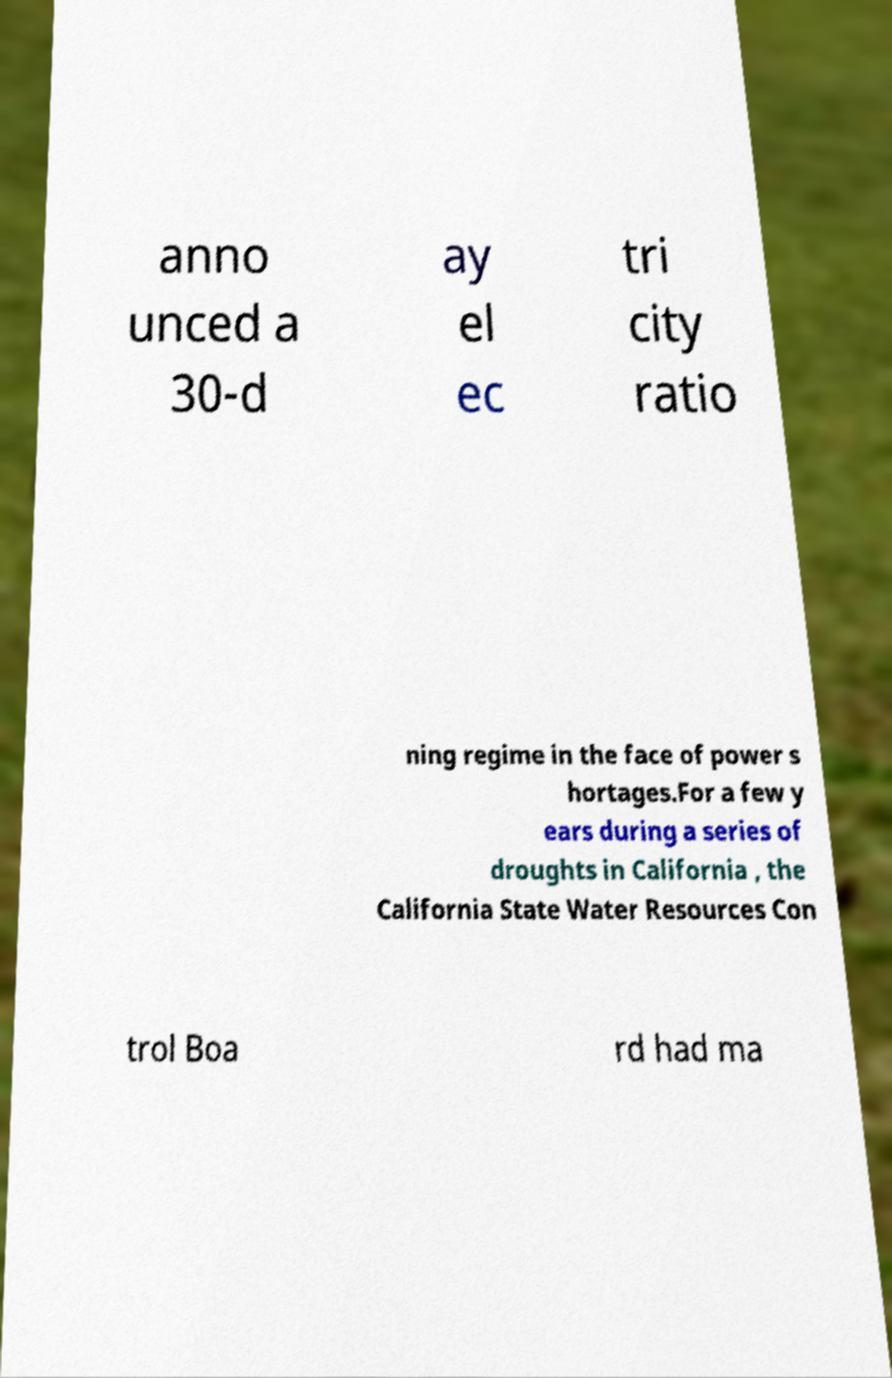Please identify and transcribe the text found in this image. anno unced a 30-d ay el ec tri city ratio ning regime in the face of power s hortages.For a few y ears during a series of droughts in California , the California State Water Resources Con trol Boa rd had ma 